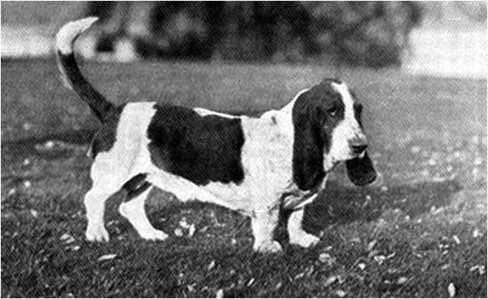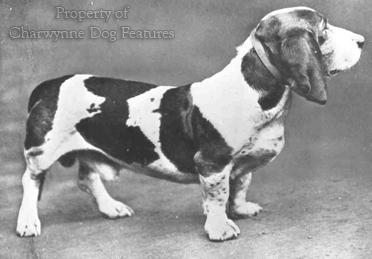The first image is the image on the left, the second image is the image on the right. Assess this claim about the two images: "Both images show at least one person standing behind a pack of hound dogs.". Correct or not? Answer yes or no. No. The first image is the image on the left, the second image is the image on the right. For the images displayed, is the sentence "There are at most one human near dogs in the image pair." factually correct? Answer yes or no. No. 